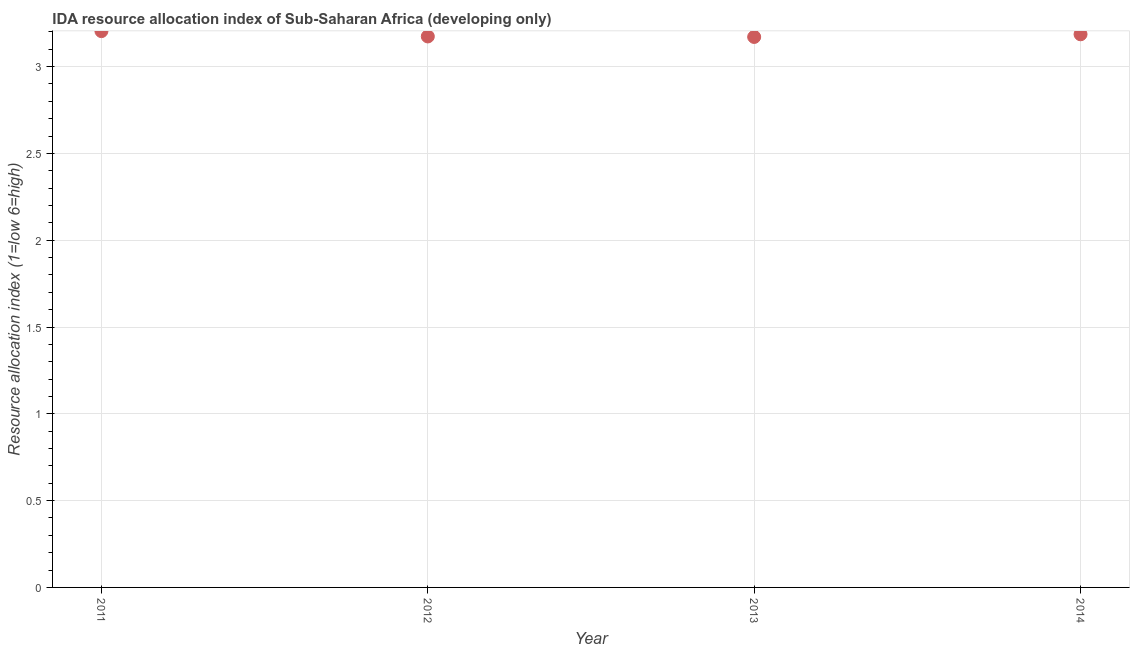What is the ida resource allocation index in 2014?
Provide a short and direct response. 3.19. Across all years, what is the maximum ida resource allocation index?
Provide a succinct answer. 3.2. Across all years, what is the minimum ida resource allocation index?
Your response must be concise. 3.17. In which year was the ida resource allocation index minimum?
Your response must be concise. 2013. What is the sum of the ida resource allocation index?
Make the answer very short. 12.74. What is the difference between the ida resource allocation index in 2012 and 2014?
Offer a terse response. -0.01. What is the average ida resource allocation index per year?
Provide a short and direct response. 3.18. What is the median ida resource allocation index?
Provide a short and direct response. 3.18. Do a majority of the years between 2012 and 2014 (inclusive) have ida resource allocation index greater than 2.6 ?
Provide a succinct answer. Yes. What is the ratio of the ida resource allocation index in 2011 to that in 2012?
Provide a short and direct response. 1.01. What is the difference between the highest and the second highest ida resource allocation index?
Offer a terse response. 0.02. What is the difference between the highest and the lowest ida resource allocation index?
Your response must be concise. 0.03. Does the ida resource allocation index monotonically increase over the years?
Keep it short and to the point. No. What is the difference between two consecutive major ticks on the Y-axis?
Keep it short and to the point. 0.5. What is the title of the graph?
Ensure brevity in your answer.  IDA resource allocation index of Sub-Saharan Africa (developing only). What is the label or title of the X-axis?
Your answer should be compact. Year. What is the label or title of the Y-axis?
Make the answer very short. Resource allocation index (1=low 6=high). What is the Resource allocation index (1=low 6=high) in 2011?
Offer a very short reply. 3.2. What is the Resource allocation index (1=low 6=high) in 2012?
Your answer should be compact. 3.17. What is the Resource allocation index (1=low 6=high) in 2013?
Your response must be concise. 3.17. What is the Resource allocation index (1=low 6=high) in 2014?
Your answer should be compact. 3.19. What is the difference between the Resource allocation index (1=low 6=high) in 2011 and 2012?
Your answer should be compact. 0.03. What is the difference between the Resource allocation index (1=low 6=high) in 2011 and 2013?
Make the answer very short. 0.03. What is the difference between the Resource allocation index (1=low 6=high) in 2011 and 2014?
Make the answer very short. 0.02. What is the difference between the Resource allocation index (1=low 6=high) in 2012 and 2013?
Keep it short and to the point. 0. What is the difference between the Resource allocation index (1=low 6=high) in 2012 and 2014?
Give a very brief answer. -0.01. What is the difference between the Resource allocation index (1=low 6=high) in 2013 and 2014?
Your answer should be very brief. -0.02. What is the ratio of the Resource allocation index (1=low 6=high) in 2011 to that in 2013?
Give a very brief answer. 1.01. What is the ratio of the Resource allocation index (1=low 6=high) in 2012 to that in 2013?
Give a very brief answer. 1. What is the ratio of the Resource allocation index (1=low 6=high) in 2012 to that in 2014?
Provide a succinct answer. 1. What is the ratio of the Resource allocation index (1=low 6=high) in 2013 to that in 2014?
Offer a very short reply. 0.99. 